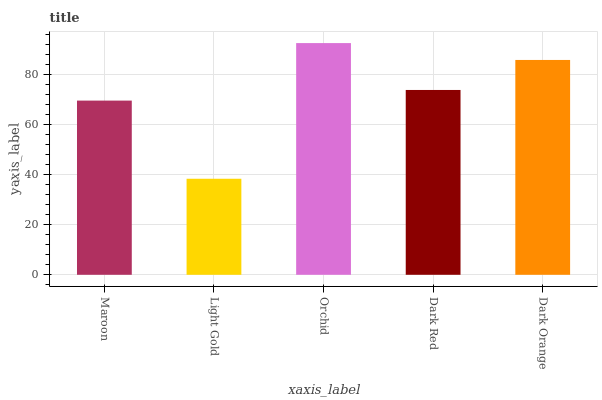Is Orchid the minimum?
Answer yes or no. No. Is Light Gold the maximum?
Answer yes or no. No. Is Orchid greater than Light Gold?
Answer yes or no. Yes. Is Light Gold less than Orchid?
Answer yes or no. Yes. Is Light Gold greater than Orchid?
Answer yes or no. No. Is Orchid less than Light Gold?
Answer yes or no. No. Is Dark Red the high median?
Answer yes or no. Yes. Is Dark Red the low median?
Answer yes or no. Yes. Is Dark Orange the high median?
Answer yes or no. No. Is Maroon the low median?
Answer yes or no. No. 